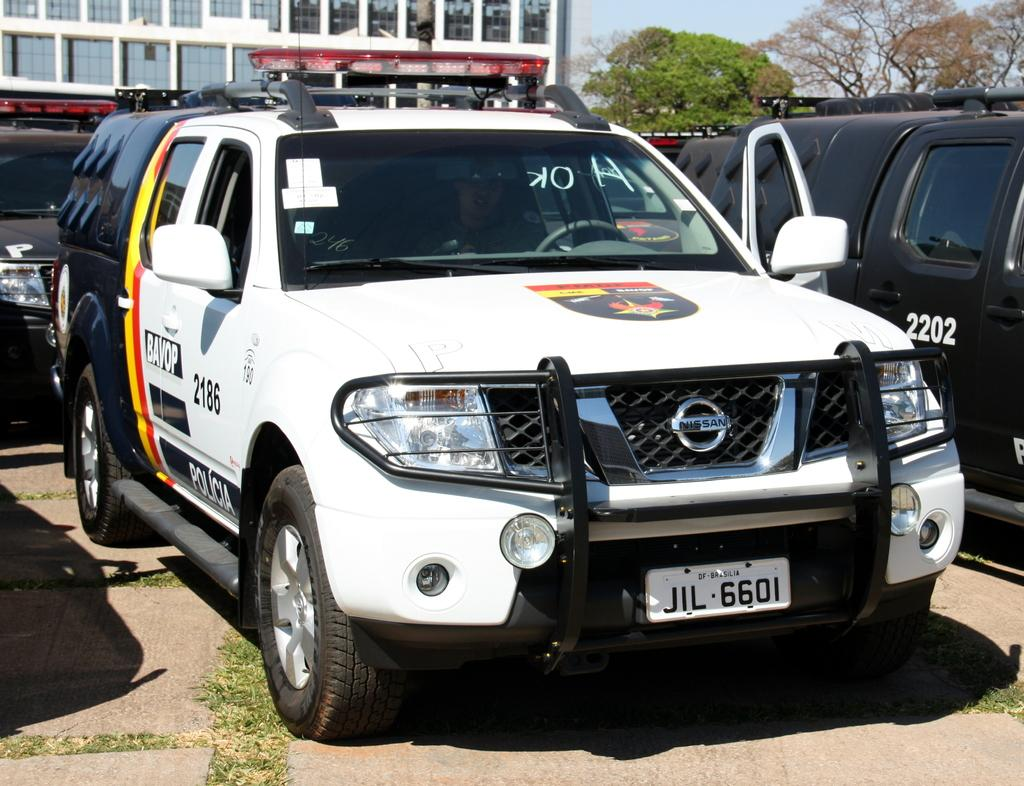What is happening on the road in the image? There are vehicles on the road in the image. What can be seen in the distance behind the vehicles? There is a building visible in the background of the image. What type of natural elements are present in the background? Trees are present in the background of the image. What is visible above the trees and building? The sky is visible in the background of the image. What type of toothbrush is being used by the trees in the image? There are no toothbrushes present in the image, as it features vehicles on the road and a background with a building, trees, and sky. 